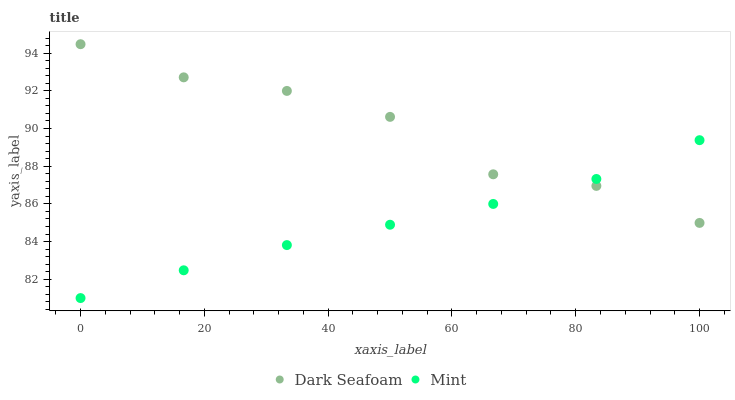Does Mint have the minimum area under the curve?
Answer yes or no. Yes. Does Dark Seafoam have the maximum area under the curve?
Answer yes or no. Yes. Does Mint have the maximum area under the curve?
Answer yes or no. No. Is Mint the smoothest?
Answer yes or no. Yes. Is Dark Seafoam the roughest?
Answer yes or no. Yes. Is Mint the roughest?
Answer yes or no. No. Does Mint have the lowest value?
Answer yes or no. Yes. Does Dark Seafoam have the highest value?
Answer yes or no. Yes. Does Mint have the highest value?
Answer yes or no. No. Does Dark Seafoam intersect Mint?
Answer yes or no. Yes. Is Dark Seafoam less than Mint?
Answer yes or no. No. Is Dark Seafoam greater than Mint?
Answer yes or no. No. 